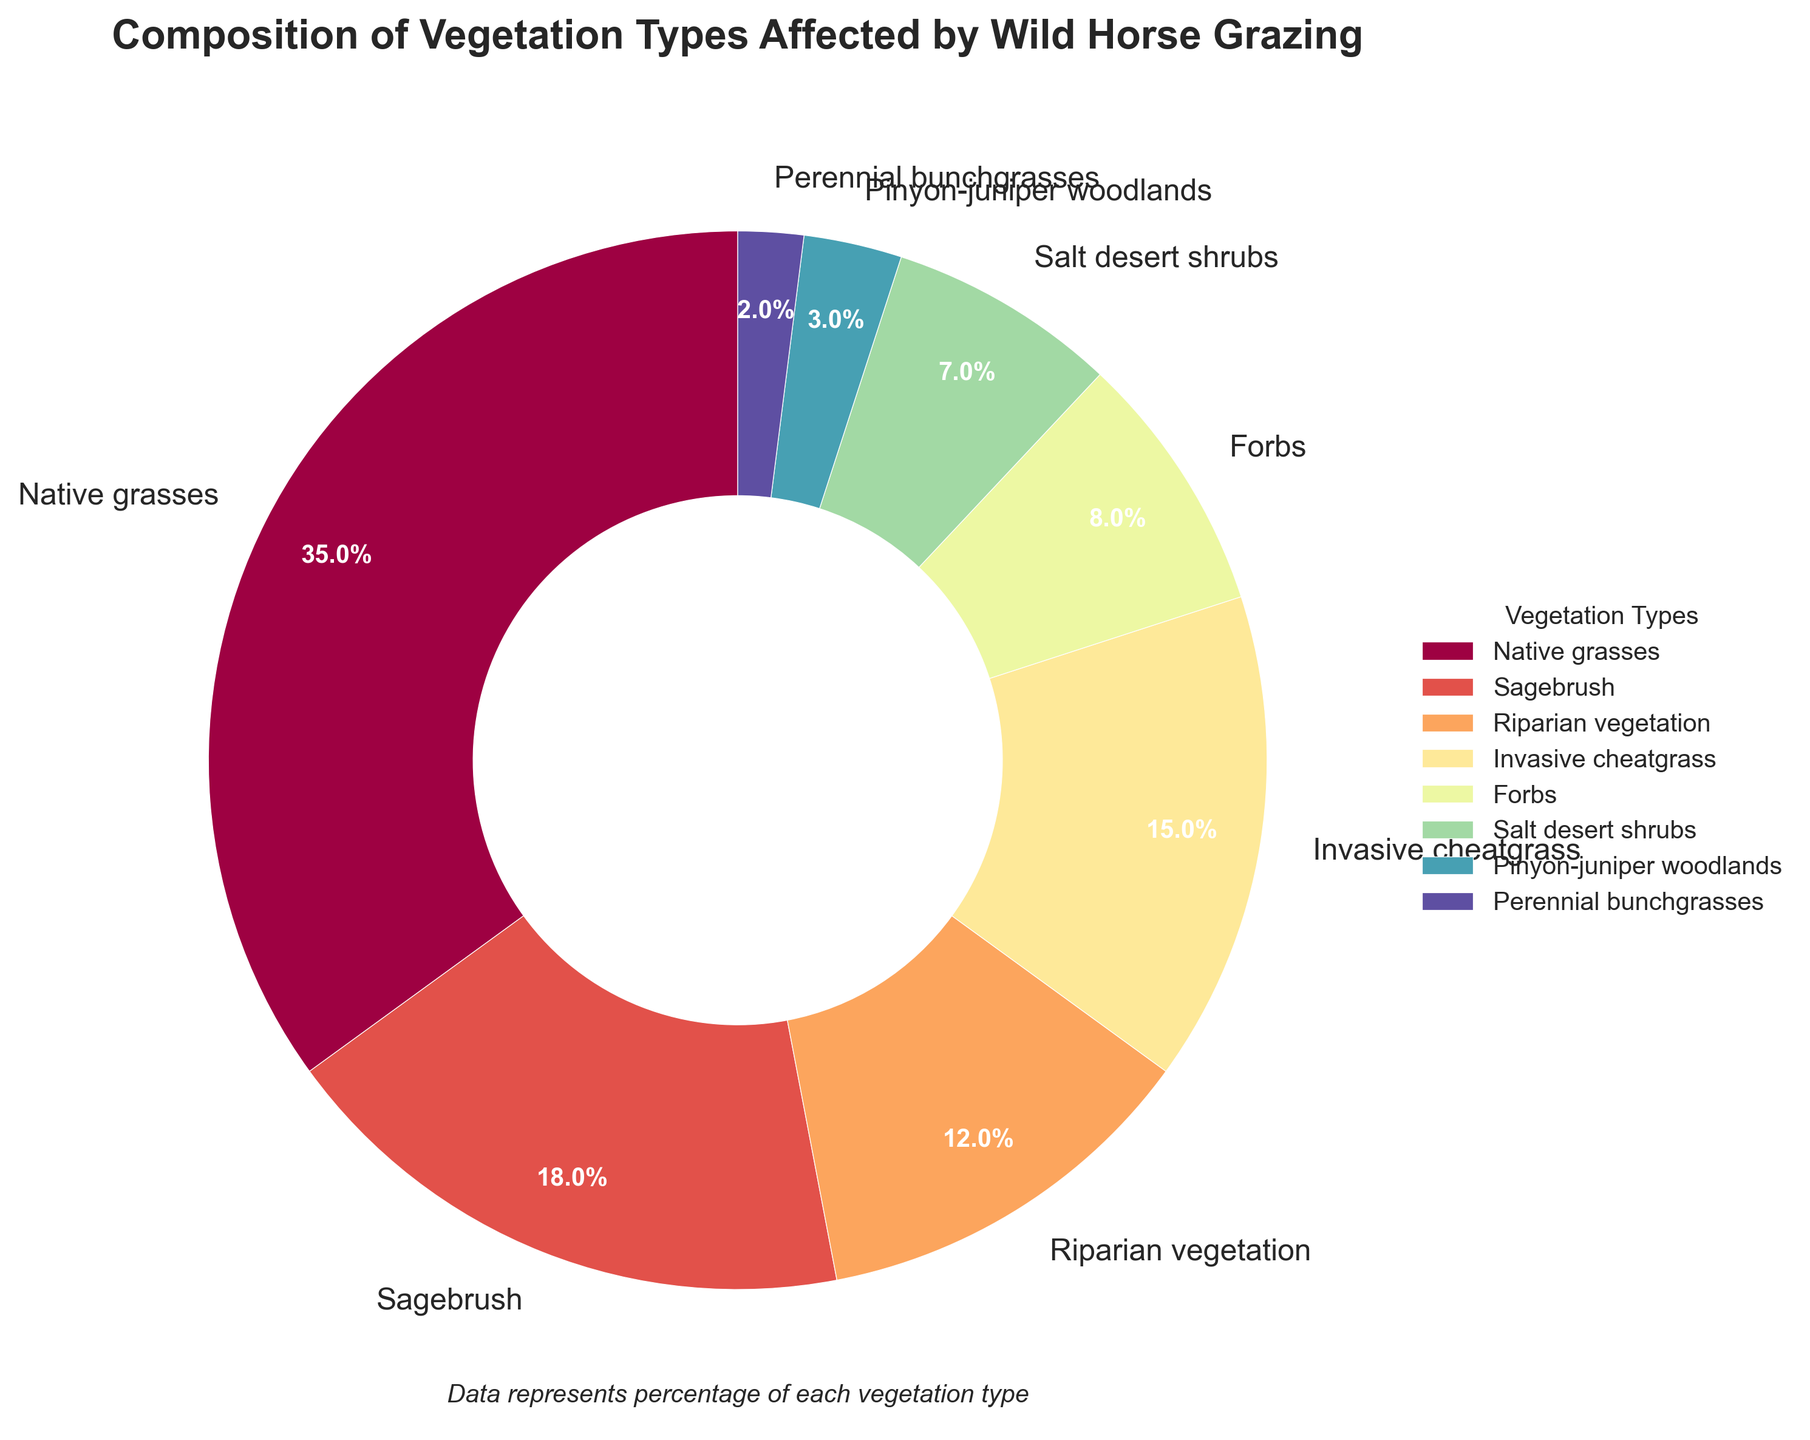What percentage of the vegetation affected by wild horse grazing is native grasses? The figure shows that 35% of the vegetation affected is labeled as native grasses.
Answer: 35% Which vegetation type has the lowest percentage affected by wild horse grazing? By examining the chart, the segment representing perennial bunchgrasses is the smallest, indicating the lowest percentage at 2%.
Answer: Perennial bunchgrasses What is the combined percentage of native grasses and sagebrush affected by wild horse grazing? The percentages provided for native grasses and sagebrush are 35% and 18%, respectively. Adding them together gives 35 + 18 = 53%.
Answer: 53% How does the area of invasive cheatgrass compare to riparian vegetation? The chart shows invasive cheatgrass at 15% and riparian vegetation at 12%. Thus, invasive cheatgrass has a higher percentage than riparian vegetation.
Answer: Invasive cheatgrass is higher Which vegetation types combined have a higher percentage than native grasses alone? Native grasses are affected at 35%. By examining the chart, the combination of invasive cheatgrass (15%) and sagebrush (18%) sums to 33%, which is less than native grasses. However, the combination of invasive cheatgrass, sagebrush, and riparian vegetation (12%) adds up to 45%, which is more.
Answer: Invasive cheatgrass, sagebrush, and riparian vegetation What percentage of the vegetation affected by wild horse grazing consists of salt desert shrubs and perennial bunchgrasses combined? The provided percentages for salt desert shrubs and perennial bunchgrasses are 7% and 2% respectively. Adding them together results in 7 + 2 = 9%.
Answer: 9% Which vegetation types appear to be affected almost equally by wild horse grazing? By examining the chart, the percentages for invasive cheatgrass and riparian vegetation are 15% and 12%, respectively, showing that they are relatively close in value.
Answer: Invasive cheatgrass and riparian vegetation Which two vegetation types together make up less than 10% of the impacted vegetation? According to the chart, perennial bunchgrasses (2%) and pinyon-juniper woodlands (3%) together combine to 2 + 3 = 5%, which is less than 10%.
Answer: Perennial bunchgrasses and pinyon-juniper woodlands What is the total percentage of all vegetation types that are not native grasses? The total percentage of all vegetation types is 100%. Subtracting the percentage for native grasses, 100 - 35 = 65%.
Answer: 65% Which vegetation type occupies the same color spectrum segment as riparian vegetation? The visual attribute of the color segments shows that both sagebrush and riparian vegetation share adjacent colors in the color spectrum used.
Answer: Sagebrush and riparian vegetation 